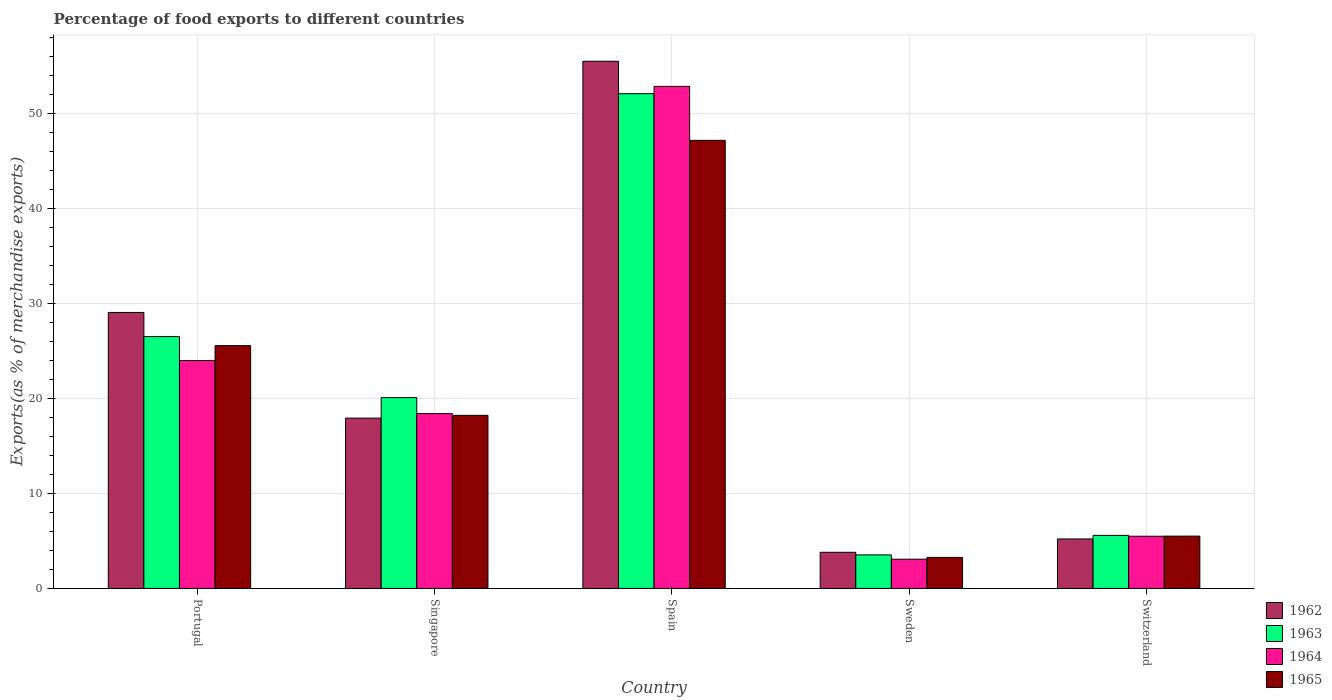How many different coloured bars are there?
Your answer should be very brief. 4. How many groups of bars are there?
Give a very brief answer. 5. Are the number of bars on each tick of the X-axis equal?
Offer a very short reply. Yes. How many bars are there on the 2nd tick from the left?
Your answer should be compact. 4. What is the label of the 3rd group of bars from the left?
Make the answer very short. Spain. In how many cases, is the number of bars for a given country not equal to the number of legend labels?
Provide a short and direct response. 0. What is the percentage of exports to different countries in 1965 in Portugal?
Your answer should be compact. 25.56. Across all countries, what is the maximum percentage of exports to different countries in 1965?
Ensure brevity in your answer.  47.17. Across all countries, what is the minimum percentage of exports to different countries in 1963?
Offer a terse response. 3.53. What is the total percentage of exports to different countries in 1963 in the graph?
Keep it short and to the point. 107.81. What is the difference between the percentage of exports to different countries in 1962 in Spain and that in Switzerland?
Your answer should be compact. 50.29. What is the difference between the percentage of exports to different countries in 1963 in Singapore and the percentage of exports to different countries in 1962 in Portugal?
Keep it short and to the point. -8.96. What is the average percentage of exports to different countries in 1964 per country?
Offer a terse response. 20.76. What is the difference between the percentage of exports to different countries of/in 1963 and percentage of exports to different countries of/in 1962 in Switzerland?
Offer a very short reply. 0.38. What is the ratio of the percentage of exports to different countries in 1963 in Portugal to that in Spain?
Give a very brief answer. 0.51. Is the percentage of exports to different countries in 1965 in Spain less than that in Switzerland?
Give a very brief answer. No. What is the difference between the highest and the second highest percentage of exports to different countries in 1962?
Offer a very short reply. -11.12. What is the difference between the highest and the lowest percentage of exports to different countries in 1962?
Your answer should be compact. 51.7. What does the 3rd bar from the left in Sweden represents?
Ensure brevity in your answer.  1964. What does the 1st bar from the right in Switzerland represents?
Offer a very short reply. 1965. Is it the case that in every country, the sum of the percentage of exports to different countries in 1964 and percentage of exports to different countries in 1962 is greater than the percentage of exports to different countries in 1963?
Offer a terse response. Yes. How many bars are there?
Offer a very short reply. 20. What is the difference between two consecutive major ticks on the Y-axis?
Your answer should be compact. 10. Are the values on the major ticks of Y-axis written in scientific E-notation?
Give a very brief answer. No. Does the graph contain any zero values?
Offer a terse response. No. How many legend labels are there?
Your answer should be very brief. 4. How are the legend labels stacked?
Your answer should be very brief. Vertical. What is the title of the graph?
Offer a terse response. Percentage of food exports to different countries. Does "1990" appear as one of the legend labels in the graph?
Give a very brief answer. No. What is the label or title of the Y-axis?
Offer a very short reply. Exports(as % of merchandise exports). What is the Exports(as % of merchandise exports) in 1962 in Portugal?
Ensure brevity in your answer.  29.05. What is the Exports(as % of merchandise exports) in 1963 in Portugal?
Keep it short and to the point. 26.51. What is the Exports(as % of merchandise exports) of 1964 in Portugal?
Your answer should be very brief. 23.99. What is the Exports(as % of merchandise exports) of 1965 in Portugal?
Your answer should be compact. 25.56. What is the Exports(as % of merchandise exports) in 1962 in Singapore?
Your response must be concise. 17.93. What is the Exports(as % of merchandise exports) in 1963 in Singapore?
Your answer should be compact. 20.09. What is the Exports(as % of merchandise exports) in 1964 in Singapore?
Provide a succinct answer. 18.41. What is the Exports(as % of merchandise exports) in 1965 in Singapore?
Ensure brevity in your answer.  18.22. What is the Exports(as % of merchandise exports) of 1962 in Spain?
Keep it short and to the point. 55.5. What is the Exports(as % of merchandise exports) of 1963 in Spain?
Offer a very short reply. 52.09. What is the Exports(as % of merchandise exports) of 1964 in Spain?
Ensure brevity in your answer.  52.85. What is the Exports(as % of merchandise exports) in 1965 in Spain?
Keep it short and to the point. 47.17. What is the Exports(as % of merchandise exports) in 1962 in Sweden?
Make the answer very short. 3.8. What is the Exports(as % of merchandise exports) of 1963 in Sweden?
Keep it short and to the point. 3.53. What is the Exports(as % of merchandise exports) of 1964 in Sweden?
Your response must be concise. 3.08. What is the Exports(as % of merchandise exports) in 1965 in Sweden?
Make the answer very short. 3.27. What is the Exports(as % of merchandise exports) in 1962 in Switzerland?
Offer a terse response. 5.21. What is the Exports(as % of merchandise exports) in 1963 in Switzerland?
Your answer should be very brief. 5.59. What is the Exports(as % of merchandise exports) in 1964 in Switzerland?
Offer a terse response. 5.49. What is the Exports(as % of merchandise exports) of 1965 in Switzerland?
Offer a very short reply. 5.51. Across all countries, what is the maximum Exports(as % of merchandise exports) of 1962?
Your answer should be compact. 55.5. Across all countries, what is the maximum Exports(as % of merchandise exports) of 1963?
Your answer should be compact. 52.09. Across all countries, what is the maximum Exports(as % of merchandise exports) of 1964?
Your response must be concise. 52.85. Across all countries, what is the maximum Exports(as % of merchandise exports) in 1965?
Keep it short and to the point. 47.17. Across all countries, what is the minimum Exports(as % of merchandise exports) in 1962?
Your answer should be very brief. 3.8. Across all countries, what is the minimum Exports(as % of merchandise exports) in 1963?
Offer a terse response. 3.53. Across all countries, what is the minimum Exports(as % of merchandise exports) in 1964?
Your answer should be compact. 3.08. Across all countries, what is the minimum Exports(as % of merchandise exports) of 1965?
Your response must be concise. 3.27. What is the total Exports(as % of merchandise exports) in 1962 in the graph?
Provide a short and direct response. 111.5. What is the total Exports(as % of merchandise exports) of 1963 in the graph?
Offer a terse response. 107.81. What is the total Exports(as % of merchandise exports) of 1964 in the graph?
Provide a short and direct response. 103.82. What is the total Exports(as % of merchandise exports) in 1965 in the graph?
Offer a very short reply. 99.73. What is the difference between the Exports(as % of merchandise exports) of 1962 in Portugal and that in Singapore?
Offer a terse response. 11.12. What is the difference between the Exports(as % of merchandise exports) of 1963 in Portugal and that in Singapore?
Offer a terse response. 6.42. What is the difference between the Exports(as % of merchandise exports) of 1964 in Portugal and that in Singapore?
Provide a succinct answer. 5.58. What is the difference between the Exports(as % of merchandise exports) of 1965 in Portugal and that in Singapore?
Keep it short and to the point. 7.34. What is the difference between the Exports(as % of merchandise exports) in 1962 in Portugal and that in Spain?
Give a very brief answer. -26.45. What is the difference between the Exports(as % of merchandise exports) of 1963 in Portugal and that in Spain?
Your answer should be compact. -25.57. What is the difference between the Exports(as % of merchandise exports) in 1964 in Portugal and that in Spain?
Offer a terse response. -28.86. What is the difference between the Exports(as % of merchandise exports) in 1965 in Portugal and that in Spain?
Your answer should be compact. -21.61. What is the difference between the Exports(as % of merchandise exports) in 1962 in Portugal and that in Sweden?
Your response must be concise. 25.25. What is the difference between the Exports(as % of merchandise exports) in 1963 in Portugal and that in Sweden?
Ensure brevity in your answer.  22.98. What is the difference between the Exports(as % of merchandise exports) in 1964 in Portugal and that in Sweden?
Offer a terse response. 20.91. What is the difference between the Exports(as % of merchandise exports) in 1965 in Portugal and that in Sweden?
Your answer should be compact. 22.29. What is the difference between the Exports(as % of merchandise exports) of 1962 in Portugal and that in Switzerland?
Provide a short and direct response. 23.85. What is the difference between the Exports(as % of merchandise exports) in 1963 in Portugal and that in Switzerland?
Provide a succinct answer. 20.93. What is the difference between the Exports(as % of merchandise exports) in 1964 in Portugal and that in Switzerland?
Keep it short and to the point. 18.5. What is the difference between the Exports(as % of merchandise exports) of 1965 in Portugal and that in Switzerland?
Provide a succinct answer. 20.05. What is the difference between the Exports(as % of merchandise exports) of 1962 in Singapore and that in Spain?
Offer a very short reply. -37.57. What is the difference between the Exports(as % of merchandise exports) in 1963 in Singapore and that in Spain?
Give a very brief answer. -31.99. What is the difference between the Exports(as % of merchandise exports) in 1964 in Singapore and that in Spain?
Ensure brevity in your answer.  -34.45. What is the difference between the Exports(as % of merchandise exports) of 1965 in Singapore and that in Spain?
Provide a short and direct response. -28.95. What is the difference between the Exports(as % of merchandise exports) in 1962 in Singapore and that in Sweden?
Make the answer very short. 14.13. What is the difference between the Exports(as % of merchandise exports) in 1963 in Singapore and that in Sweden?
Provide a short and direct response. 16.56. What is the difference between the Exports(as % of merchandise exports) in 1964 in Singapore and that in Sweden?
Your answer should be compact. 15.33. What is the difference between the Exports(as % of merchandise exports) in 1965 in Singapore and that in Sweden?
Make the answer very short. 14.95. What is the difference between the Exports(as % of merchandise exports) of 1962 in Singapore and that in Switzerland?
Your response must be concise. 12.72. What is the difference between the Exports(as % of merchandise exports) of 1963 in Singapore and that in Switzerland?
Give a very brief answer. 14.51. What is the difference between the Exports(as % of merchandise exports) of 1964 in Singapore and that in Switzerland?
Make the answer very short. 12.91. What is the difference between the Exports(as % of merchandise exports) of 1965 in Singapore and that in Switzerland?
Ensure brevity in your answer.  12.71. What is the difference between the Exports(as % of merchandise exports) of 1962 in Spain and that in Sweden?
Your response must be concise. 51.7. What is the difference between the Exports(as % of merchandise exports) in 1963 in Spain and that in Sweden?
Provide a short and direct response. 48.56. What is the difference between the Exports(as % of merchandise exports) of 1964 in Spain and that in Sweden?
Ensure brevity in your answer.  49.77. What is the difference between the Exports(as % of merchandise exports) of 1965 in Spain and that in Sweden?
Provide a succinct answer. 43.9. What is the difference between the Exports(as % of merchandise exports) in 1962 in Spain and that in Switzerland?
Your answer should be very brief. 50.29. What is the difference between the Exports(as % of merchandise exports) in 1963 in Spain and that in Switzerland?
Offer a terse response. 46.5. What is the difference between the Exports(as % of merchandise exports) of 1964 in Spain and that in Switzerland?
Ensure brevity in your answer.  47.36. What is the difference between the Exports(as % of merchandise exports) of 1965 in Spain and that in Switzerland?
Your answer should be very brief. 41.67. What is the difference between the Exports(as % of merchandise exports) in 1962 in Sweden and that in Switzerland?
Your answer should be compact. -1.4. What is the difference between the Exports(as % of merchandise exports) in 1963 in Sweden and that in Switzerland?
Your answer should be compact. -2.06. What is the difference between the Exports(as % of merchandise exports) of 1964 in Sweden and that in Switzerland?
Provide a short and direct response. -2.41. What is the difference between the Exports(as % of merchandise exports) in 1965 in Sweden and that in Switzerland?
Offer a terse response. -2.24. What is the difference between the Exports(as % of merchandise exports) of 1962 in Portugal and the Exports(as % of merchandise exports) of 1963 in Singapore?
Provide a succinct answer. 8.96. What is the difference between the Exports(as % of merchandise exports) in 1962 in Portugal and the Exports(as % of merchandise exports) in 1964 in Singapore?
Offer a very short reply. 10.65. What is the difference between the Exports(as % of merchandise exports) in 1962 in Portugal and the Exports(as % of merchandise exports) in 1965 in Singapore?
Keep it short and to the point. 10.83. What is the difference between the Exports(as % of merchandise exports) of 1963 in Portugal and the Exports(as % of merchandise exports) of 1964 in Singapore?
Keep it short and to the point. 8.11. What is the difference between the Exports(as % of merchandise exports) in 1963 in Portugal and the Exports(as % of merchandise exports) in 1965 in Singapore?
Make the answer very short. 8.29. What is the difference between the Exports(as % of merchandise exports) in 1964 in Portugal and the Exports(as % of merchandise exports) in 1965 in Singapore?
Offer a very short reply. 5.77. What is the difference between the Exports(as % of merchandise exports) of 1962 in Portugal and the Exports(as % of merchandise exports) of 1963 in Spain?
Offer a very short reply. -23.03. What is the difference between the Exports(as % of merchandise exports) of 1962 in Portugal and the Exports(as % of merchandise exports) of 1964 in Spain?
Ensure brevity in your answer.  -23.8. What is the difference between the Exports(as % of merchandise exports) in 1962 in Portugal and the Exports(as % of merchandise exports) in 1965 in Spain?
Provide a succinct answer. -18.12. What is the difference between the Exports(as % of merchandise exports) of 1963 in Portugal and the Exports(as % of merchandise exports) of 1964 in Spain?
Offer a terse response. -26.34. What is the difference between the Exports(as % of merchandise exports) of 1963 in Portugal and the Exports(as % of merchandise exports) of 1965 in Spain?
Your answer should be very brief. -20.66. What is the difference between the Exports(as % of merchandise exports) in 1964 in Portugal and the Exports(as % of merchandise exports) in 1965 in Spain?
Provide a succinct answer. -23.18. What is the difference between the Exports(as % of merchandise exports) of 1962 in Portugal and the Exports(as % of merchandise exports) of 1963 in Sweden?
Your answer should be very brief. 25.53. What is the difference between the Exports(as % of merchandise exports) of 1962 in Portugal and the Exports(as % of merchandise exports) of 1964 in Sweden?
Ensure brevity in your answer.  25.98. What is the difference between the Exports(as % of merchandise exports) in 1962 in Portugal and the Exports(as % of merchandise exports) in 1965 in Sweden?
Your answer should be very brief. 25.79. What is the difference between the Exports(as % of merchandise exports) in 1963 in Portugal and the Exports(as % of merchandise exports) in 1964 in Sweden?
Your answer should be compact. 23.44. What is the difference between the Exports(as % of merchandise exports) of 1963 in Portugal and the Exports(as % of merchandise exports) of 1965 in Sweden?
Ensure brevity in your answer.  23.25. What is the difference between the Exports(as % of merchandise exports) of 1964 in Portugal and the Exports(as % of merchandise exports) of 1965 in Sweden?
Offer a very short reply. 20.72. What is the difference between the Exports(as % of merchandise exports) of 1962 in Portugal and the Exports(as % of merchandise exports) of 1963 in Switzerland?
Ensure brevity in your answer.  23.47. What is the difference between the Exports(as % of merchandise exports) in 1962 in Portugal and the Exports(as % of merchandise exports) in 1964 in Switzerland?
Offer a very short reply. 23.56. What is the difference between the Exports(as % of merchandise exports) of 1962 in Portugal and the Exports(as % of merchandise exports) of 1965 in Switzerland?
Keep it short and to the point. 23.55. What is the difference between the Exports(as % of merchandise exports) in 1963 in Portugal and the Exports(as % of merchandise exports) in 1964 in Switzerland?
Your answer should be compact. 21.02. What is the difference between the Exports(as % of merchandise exports) in 1963 in Portugal and the Exports(as % of merchandise exports) in 1965 in Switzerland?
Give a very brief answer. 21.01. What is the difference between the Exports(as % of merchandise exports) in 1964 in Portugal and the Exports(as % of merchandise exports) in 1965 in Switzerland?
Provide a succinct answer. 18.48. What is the difference between the Exports(as % of merchandise exports) of 1962 in Singapore and the Exports(as % of merchandise exports) of 1963 in Spain?
Give a very brief answer. -34.16. What is the difference between the Exports(as % of merchandise exports) in 1962 in Singapore and the Exports(as % of merchandise exports) in 1964 in Spain?
Your answer should be compact. -34.92. What is the difference between the Exports(as % of merchandise exports) of 1962 in Singapore and the Exports(as % of merchandise exports) of 1965 in Spain?
Keep it short and to the point. -29.24. What is the difference between the Exports(as % of merchandise exports) in 1963 in Singapore and the Exports(as % of merchandise exports) in 1964 in Spain?
Offer a terse response. -32.76. What is the difference between the Exports(as % of merchandise exports) of 1963 in Singapore and the Exports(as % of merchandise exports) of 1965 in Spain?
Offer a terse response. -27.08. What is the difference between the Exports(as % of merchandise exports) in 1964 in Singapore and the Exports(as % of merchandise exports) in 1965 in Spain?
Offer a very short reply. -28.77. What is the difference between the Exports(as % of merchandise exports) of 1962 in Singapore and the Exports(as % of merchandise exports) of 1963 in Sweden?
Your answer should be very brief. 14.4. What is the difference between the Exports(as % of merchandise exports) of 1962 in Singapore and the Exports(as % of merchandise exports) of 1964 in Sweden?
Your answer should be compact. 14.85. What is the difference between the Exports(as % of merchandise exports) in 1962 in Singapore and the Exports(as % of merchandise exports) in 1965 in Sweden?
Make the answer very short. 14.66. What is the difference between the Exports(as % of merchandise exports) in 1963 in Singapore and the Exports(as % of merchandise exports) in 1964 in Sweden?
Make the answer very short. 17.01. What is the difference between the Exports(as % of merchandise exports) of 1963 in Singapore and the Exports(as % of merchandise exports) of 1965 in Sweden?
Make the answer very short. 16.83. What is the difference between the Exports(as % of merchandise exports) of 1964 in Singapore and the Exports(as % of merchandise exports) of 1965 in Sweden?
Offer a very short reply. 15.14. What is the difference between the Exports(as % of merchandise exports) in 1962 in Singapore and the Exports(as % of merchandise exports) in 1963 in Switzerland?
Provide a short and direct response. 12.34. What is the difference between the Exports(as % of merchandise exports) of 1962 in Singapore and the Exports(as % of merchandise exports) of 1964 in Switzerland?
Your response must be concise. 12.44. What is the difference between the Exports(as % of merchandise exports) of 1962 in Singapore and the Exports(as % of merchandise exports) of 1965 in Switzerland?
Ensure brevity in your answer.  12.42. What is the difference between the Exports(as % of merchandise exports) of 1963 in Singapore and the Exports(as % of merchandise exports) of 1964 in Switzerland?
Your response must be concise. 14.6. What is the difference between the Exports(as % of merchandise exports) of 1963 in Singapore and the Exports(as % of merchandise exports) of 1965 in Switzerland?
Provide a succinct answer. 14.59. What is the difference between the Exports(as % of merchandise exports) of 1964 in Singapore and the Exports(as % of merchandise exports) of 1965 in Switzerland?
Make the answer very short. 12.9. What is the difference between the Exports(as % of merchandise exports) of 1962 in Spain and the Exports(as % of merchandise exports) of 1963 in Sweden?
Ensure brevity in your answer.  51.97. What is the difference between the Exports(as % of merchandise exports) in 1962 in Spain and the Exports(as % of merchandise exports) in 1964 in Sweden?
Your answer should be very brief. 52.42. What is the difference between the Exports(as % of merchandise exports) of 1962 in Spain and the Exports(as % of merchandise exports) of 1965 in Sweden?
Your response must be concise. 52.23. What is the difference between the Exports(as % of merchandise exports) in 1963 in Spain and the Exports(as % of merchandise exports) in 1964 in Sweden?
Your response must be concise. 49.01. What is the difference between the Exports(as % of merchandise exports) of 1963 in Spain and the Exports(as % of merchandise exports) of 1965 in Sweden?
Provide a short and direct response. 48.82. What is the difference between the Exports(as % of merchandise exports) in 1964 in Spain and the Exports(as % of merchandise exports) in 1965 in Sweden?
Make the answer very short. 49.58. What is the difference between the Exports(as % of merchandise exports) of 1962 in Spain and the Exports(as % of merchandise exports) of 1963 in Switzerland?
Give a very brief answer. 49.92. What is the difference between the Exports(as % of merchandise exports) in 1962 in Spain and the Exports(as % of merchandise exports) in 1964 in Switzerland?
Provide a succinct answer. 50.01. What is the difference between the Exports(as % of merchandise exports) in 1962 in Spain and the Exports(as % of merchandise exports) in 1965 in Switzerland?
Your response must be concise. 49.99. What is the difference between the Exports(as % of merchandise exports) in 1963 in Spain and the Exports(as % of merchandise exports) in 1964 in Switzerland?
Your answer should be compact. 46.59. What is the difference between the Exports(as % of merchandise exports) of 1963 in Spain and the Exports(as % of merchandise exports) of 1965 in Switzerland?
Your answer should be very brief. 46.58. What is the difference between the Exports(as % of merchandise exports) of 1964 in Spain and the Exports(as % of merchandise exports) of 1965 in Switzerland?
Ensure brevity in your answer.  47.35. What is the difference between the Exports(as % of merchandise exports) of 1962 in Sweden and the Exports(as % of merchandise exports) of 1963 in Switzerland?
Make the answer very short. -1.78. What is the difference between the Exports(as % of merchandise exports) of 1962 in Sweden and the Exports(as % of merchandise exports) of 1964 in Switzerland?
Provide a short and direct response. -1.69. What is the difference between the Exports(as % of merchandise exports) of 1962 in Sweden and the Exports(as % of merchandise exports) of 1965 in Switzerland?
Your answer should be very brief. -1.7. What is the difference between the Exports(as % of merchandise exports) in 1963 in Sweden and the Exports(as % of merchandise exports) in 1964 in Switzerland?
Give a very brief answer. -1.96. What is the difference between the Exports(as % of merchandise exports) of 1963 in Sweden and the Exports(as % of merchandise exports) of 1965 in Switzerland?
Make the answer very short. -1.98. What is the difference between the Exports(as % of merchandise exports) of 1964 in Sweden and the Exports(as % of merchandise exports) of 1965 in Switzerland?
Provide a short and direct response. -2.43. What is the average Exports(as % of merchandise exports) of 1962 per country?
Your response must be concise. 22.3. What is the average Exports(as % of merchandise exports) in 1963 per country?
Ensure brevity in your answer.  21.56. What is the average Exports(as % of merchandise exports) of 1964 per country?
Provide a succinct answer. 20.76. What is the average Exports(as % of merchandise exports) of 1965 per country?
Make the answer very short. 19.95. What is the difference between the Exports(as % of merchandise exports) of 1962 and Exports(as % of merchandise exports) of 1963 in Portugal?
Keep it short and to the point. 2.54. What is the difference between the Exports(as % of merchandise exports) of 1962 and Exports(as % of merchandise exports) of 1964 in Portugal?
Keep it short and to the point. 5.06. What is the difference between the Exports(as % of merchandise exports) of 1962 and Exports(as % of merchandise exports) of 1965 in Portugal?
Provide a succinct answer. 3.49. What is the difference between the Exports(as % of merchandise exports) of 1963 and Exports(as % of merchandise exports) of 1964 in Portugal?
Make the answer very short. 2.52. What is the difference between the Exports(as % of merchandise exports) in 1963 and Exports(as % of merchandise exports) in 1965 in Portugal?
Offer a very short reply. 0.95. What is the difference between the Exports(as % of merchandise exports) in 1964 and Exports(as % of merchandise exports) in 1965 in Portugal?
Offer a terse response. -1.57. What is the difference between the Exports(as % of merchandise exports) of 1962 and Exports(as % of merchandise exports) of 1963 in Singapore?
Provide a short and direct response. -2.16. What is the difference between the Exports(as % of merchandise exports) of 1962 and Exports(as % of merchandise exports) of 1964 in Singapore?
Provide a succinct answer. -0.48. What is the difference between the Exports(as % of merchandise exports) of 1962 and Exports(as % of merchandise exports) of 1965 in Singapore?
Keep it short and to the point. -0.29. What is the difference between the Exports(as % of merchandise exports) of 1963 and Exports(as % of merchandise exports) of 1964 in Singapore?
Offer a very short reply. 1.69. What is the difference between the Exports(as % of merchandise exports) of 1963 and Exports(as % of merchandise exports) of 1965 in Singapore?
Provide a short and direct response. 1.87. What is the difference between the Exports(as % of merchandise exports) of 1964 and Exports(as % of merchandise exports) of 1965 in Singapore?
Your answer should be very brief. 0.18. What is the difference between the Exports(as % of merchandise exports) of 1962 and Exports(as % of merchandise exports) of 1963 in Spain?
Your response must be concise. 3.42. What is the difference between the Exports(as % of merchandise exports) in 1962 and Exports(as % of merchandise exports) in 1964 in Spain?
Your answer should be very brief. 2.65. What is the difference between the Exports(as % of merchandise exports) of 1962 and Exports(as % of merchandise exports) of 1965 in Spain?
Make the answer very short. 8.33. What is the difference between the Exports(as % of merchandise exports) in 1963 and Exports(as % of merchandise exports) in 1964 in Spain?
Your answer should be compact. -0.77. What is the difference between the Exports(as % of merchandise exports) of 1963 and Exports(as % of merchandise exports) of 1965 in Spain?
Offer a terse response. 4.91. What is the difference between the Exports(as % of merchandise exports) in 1964 and Exports(as % of merchandise exports) in 1965 in Spain?
Offer a terse response. 5.68. What is the difference between the Exports(as % of merchandise exports) of 1962 and Exports(as % of merchandise exports) of 1963 in Sweden?
Keep it short and to the point. 0.28. What is the difference between the Exports(as % of merchandise exports) of 1962 and Exports(as % of merchandise exports) of 1964 in Sweden?
Keep it short and to the point. 0.73. What is the difference between the Exports(as % of merchandise exports) in 1962 and Exports(as % of merchandise exports) in 1965 in Sweden?
Give a very brief answer. 0.54. What is the difference between the Exports(as % of merchandise exports) of 1963 and Exports(as % of merchandise exports) of 1964 in Sweden?
Offer a very short reply. 0.45. What is the difference between the Exports(as % of merchandise exports) in 1963 and Exports(as % of merchandise exports) in 1965 in Sweden?
Provide a short and direct response. 0.26. What is the difference between the Exports(as % of merchandise exports) in 1964 and Exports(as % of merchandise exports) in 1965 in Sweden?
Provide a succinct answer. -0.19. What is the difference between the Exports(as % of merchandise exports) in 1962 and Exports(as % of merchandise exports) in 1963 in Switzerland?
Make the answer very short. -0.38. What is the difference between the Exports(as % of merchandise exports) in 1962 and Exports(as % of merchandise exports) in 1964 in Switzerland?
Give a very brief answer. -0.28. What is the difference between the Exports(as % of merchandise exports) in 1962 and Exports(as % of merchandise exports) in 1965 in Switzerland?
Give a very brief answer. -0.3. What is the difference between the Exports(as % of merchandise exports) of 1963 and Exports(as % of merchandise exports) of 1964 in Switzerland?
Make the answer very short. 0.09. What is the difference between the Exports(as % of merchandise exports) of 1963 and Exports(as % of merchandise exports) of 1965 in Switzerland?
Provide a short and direct response. 0.08. What is the difference between the Exports(as % of merchandise exports) in 1964 and Exports(as % of merchandise exports) in 1965 in Switzerland?
Provide a short and direct response. -0.01. What is the ratio of the Exports(as % of merchandise exports) in 1962 in Portugal to that in Singapore?
Offer a very short reply. 1.62. What is the ratio of the Exports(as % of merchandise exports) of 1963 in Portugal to that in Singapore?
Offer a terse response. 1.32. What is the ratio of the Exports(as % of merchandise exports) of 1964 in Portugal to that in Singapore?
Your answer should be very brief. 1.3. What is the ratio of the Exports(as % of merchandise exports) in 1965 in Portugal to that in Singapore?
Ensure brevity in your answer.  1.4. What is the ratio of the Exports(as % of merchandise exports) in 1962 in Portugal to that in Spain?
Make the answer very short. 0.52. What is the ratio of the Exports(as % of merchandise exports) of 1963 in Portugal to that in Spain?
Your response must be concise. 0.51. What is the ratio of the Exports(as % of merchandise exports) of 1964 in Portugal to that in Spain?
Ensure brevity in your answer.  0.45. What is the ratio of the Exports(as % of merchandise exports) of 1965 in Portugal to that in Spain?
Your answer should be very brief. 0.54. What is the ratio of the Exports(as % of merchandise exports) of 1962 in Portugal to that in Sweden?
Your response must be concise. 7.64. What is the ratio of the Exports(as % of merchandise exports) of 1963 in Portugal to that in Sweden?
Your response must be concise. 7.51. What is the ratio of the Exports(as % of merchandise exports) of 1964 in Portugal to that in Sweden?
Offer a terse response. 7.79. What is the ratio of the Exports(as % of merchandise exports) of 1965 in Portugal to that in Sweden?
Provide a short and direct response. 7.82. What is the ratio of the Exports(as % of merchandise exports) of 1962 in Portugal to that in Switzerland?
Provide a succinct answer. 5.58. What is the ratio of the Exports(as % of merchandise exports) of 1963 in Portugal to that in Switzerland?
Provide a short and direct response. 4.75. What is the ratio of the Exports(as % of merchandise exports) in 1964 in Portugal to that in Switzerland?
Offer a very short reply. 4.37. What is the ratio of the Exports(as % of merchandise exports) in 1965 in Portugal to that in Switzerland?
Provide a short and direct response. 4.64. What is the ratio of the Exports(as % of merchandise exports) in 1962 in Singapore to that in Spain?
Make the answer very short. 0.32. What is the ratio of the Exports(as % of merchandise exports) in 1963 in Singapore to that in Spain?
Keep it short and to the point. 0.39. What is the ratio of the Exports(as % of merchandise exports) in 1964 in Singapore to that in Spain?
Your response must be concise. 0.35. What is the ratio of the Exports(as % of merchandise exports) of 1965 in Singapore to that in Spain?
Provide a short and direct response. 0.39. What is the ratio of the Exports(as % of merchandise exports) of 1962 in Singapore to that in Sweden?
Provide a short and direct response. 4.71. What is the ratio of the Exports(as % of merchandise exports) in 1963 in Singapore to that in Sweden?
Provide a succinct answer. 5.69. What is the ratio of the Exports(as % of merchandise exports) in 1964 in Singapore to that in Sweden?
Make the answer very short. 5.98. What is the ratio of the Exports(as % of merchandise exports) in 1965 in Singapore to that in Sweden?
Your response must be concise. 5.58. What is the ratio of the Exports(as % of merchandise exports) of 1962 in Singapore to that in Switzerland?
Your response must be concise. 3.44. What is the ratio of the Exports(as % of merchandise exports) in 1963 in Singapore to that in Switzerland?
Give a very brief answer. 3.6. What is the ratio of the Exports(as % of merchandise exports) in 1964 in Singapore to that in Switzerland?
Keep it short and to the point. 3.35. What is the ratio of the Exports(as % of merchandise exports) in 1965 in Singapore to that in Switzerland?
Offer a very short reply. 3.31. What is the ratio of the Exports(as % of merchandise exports) of 1962 in Spain to that in Sweden?
Make the answer very short. 14.59. What is the ratio of the Exports(as % of merchandise exports) in 1963 in Spain to that in Sweden?
Give a very brief answer. 14.76. What is the ratio of the Exports(as % of merchandise exports) of 1964 in Spain to that in Sweden?
Keep it short and to the point. 17.17. What is the ratio of the Exports(as % of merchandise exports) in 1965 in Spain to that in Sweden?
Give a very brief answer. 14.44. What is the ratio of the Exports(as % of merchandise exports) in 1962 in Spain to that in Switzerland?
Provide a succinct answer. 10.65. What is the ratio of the Exports(as % of merchandise exports) of 1963 in Spain to that in Switzerland?
Your answer should be compact. 9.33. What is the ratio of the Exports(as % of merchandise exports) of 1964 in Spain to that in Switzerland?
Make the answer very short. 9.62. What is the ratio of the Exports(as % of merchandise exports) in 1965 in Spain to that in Switzerland?
Offer a very short reply. 8.57. What is the ratio of the Exports(as % of merchandise exports) in 1962 in Sweden to that in Switzerland?
Offer a terse response. 0.73. What is the ratio of the Exports(as % of merchandise exports) of 1963 in Sweden to that in Switzerland?
Your answer should be very brief. 0.63. What is the ratio of the Exports(as % of merchandise exports) of 1964 in Sweden to that in Switzerland?
Provide a succinct answer. 0.56. What is the ratio of the Exports(as % of merchandise exports) in 1965 in Sweden to that in Switzerland?
Ensure brevity in your answer.  0.59. What is the difference between the highest and the second highest Exports(as % of merchandise exports) in 1962?
Provide a short and direct response. 26.45. What is the difference between the highest and the second highest Exports(as % of merchandise exports) of 1963?
Ensure brevity in your answer.  25.57. What is the difference between the highest and the second highest Exports(as % of merchandise exports) of 1964?
Keep it short and to the point. 28.86. What is the difference between the highest and the second highest Exports(as % of merchandise exports) of 1965?
Provide a short and direct response. 21.61. What is the difference between the highest and the lowest Exports(as % of merchandise exports) of 1962?
Offer a terse response. 51.7. What is the difference between the highest and the lowest Exports(as % of merchandise exports) in 1963?
Offer a terse response. 48.56. What is the difference between the highest and the lowest Exports(as % of merchandise exports) of 1964?
Your answer should be very brief. 49.77. What is the difference between the highest and the lowest Exports(as % of merchandise exports) in 1965?
Offer a terse response. 43.9. 